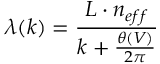<formula> <loc_0><loc_0><loc_500><loc_500>\lambda ( k ) = \frac { L \cdot n _ { e f f } } { k + \frac { \theta ( V ) } { 2 \pi } }</formula> 